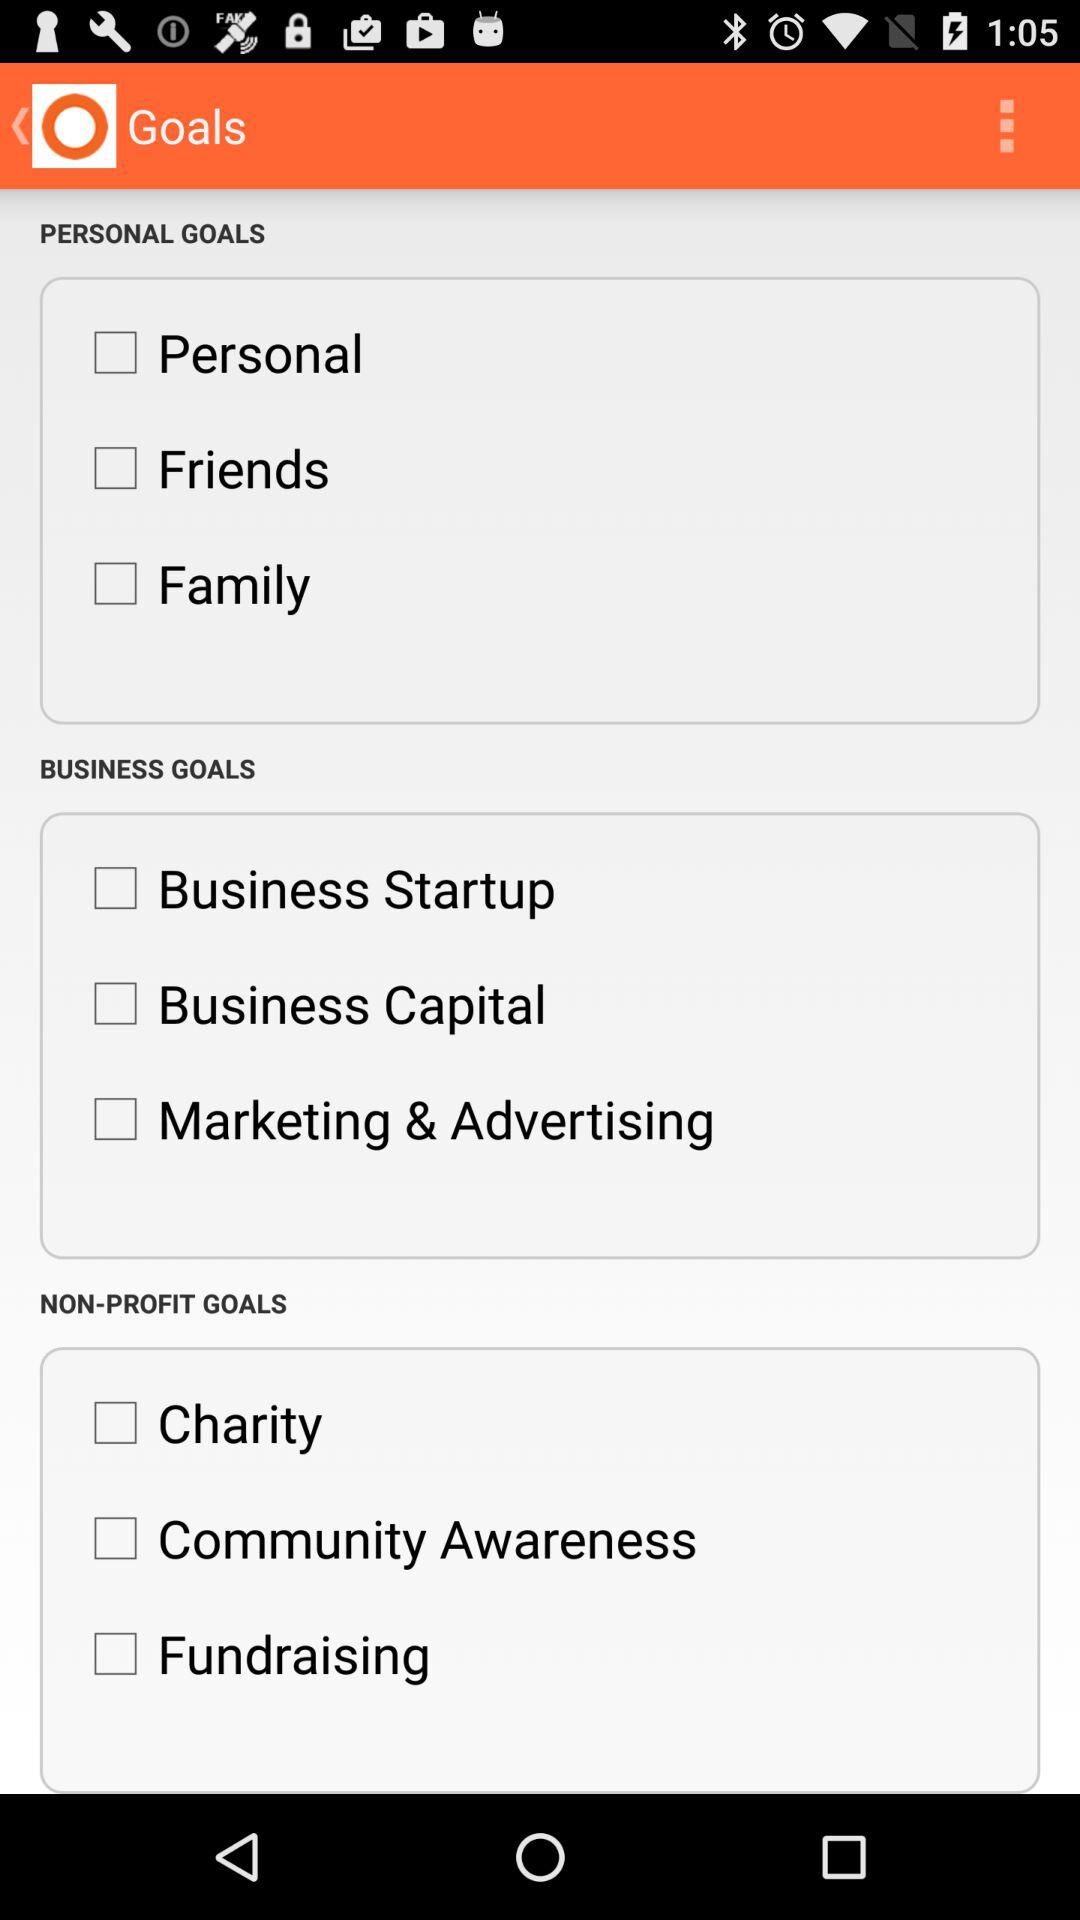What is the name of the application?
When the provided information is insufficient, respond with <no answer>. <no answer> 